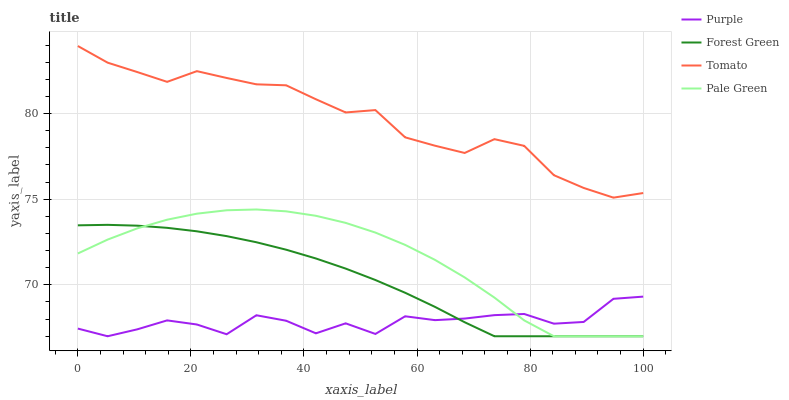Does Forest Green have the minimum area under the curve?
Answer yes or no. No. Does Forest Green have the maximum area under the curve?
Answer yes or no. No. Is Tomato the smoothest?
Answer yes or no. No. Is Tomato the roughest?
Answer yes or no. No. Does Tomato have the lowest value?
Answer yes or no. No. Does Forest Green have the highest value?
Answer yes or no. No. Is Pale Green less than Tomato?
Answer yes or no. Yes. Is Tomato greater than Pale Green?
Answer yes or no. Yes. Does Pale Green intersect Tomato?
Answer yes or no. No. 